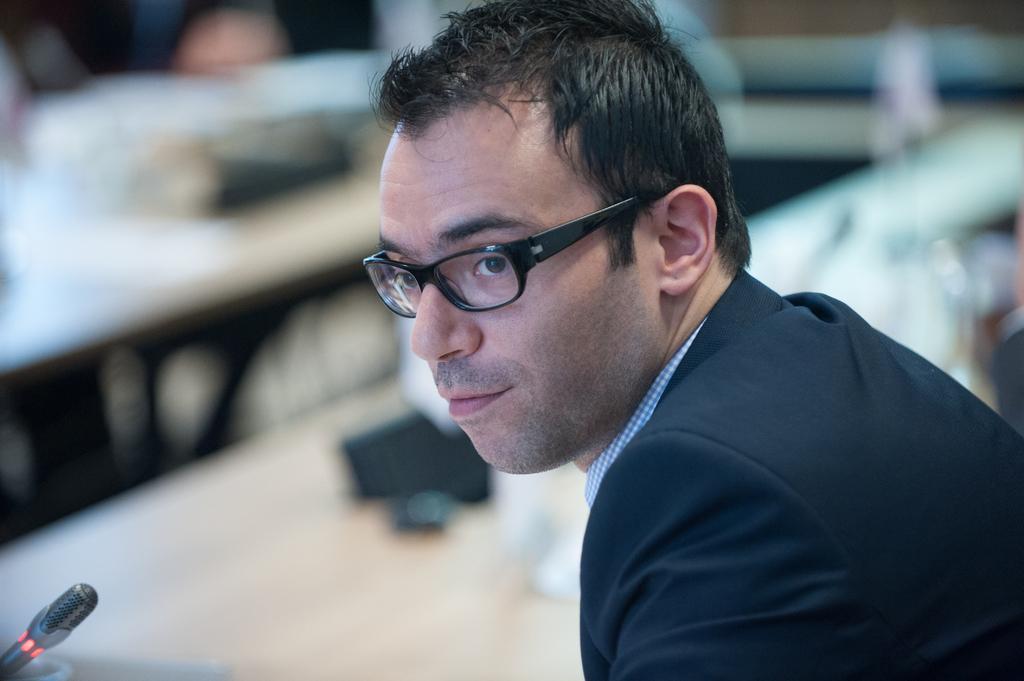Can you describe this image briefly? In this image I can see a person wearing black colored dress and black colored spectacles. I can see a microphone in front of him and the blurry background. 